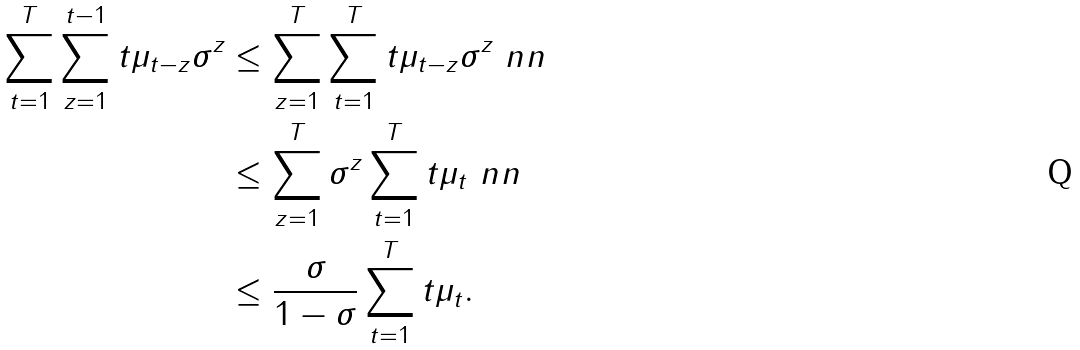Convert formula to latex. <formula><loc_0><loc_0><loc_500><loc_500>\sum _ { t = 1 } ^ { T } \sum _ { z = 1 } ^ { t - 1 } t \mu _ { t - z } \sigma ^ { z } & \leq \sum _ { z = 1 } ^ { T } \sum _ { t = 1 } ^ { T } t \mu _ { t - z } \sigma ^ { z } \ n n \\ & \leq \sum _ { z = 1 } ^ { T } \sigma ^ { z } \sum _ { t = 1 } ^ { T } t \mu _ { t } \ n n \\ & \leq \frac { \sigma } { 1 - \sigma } \sum _ { t = 1 } ^ { T } t \mu _ { t } .</formula> 